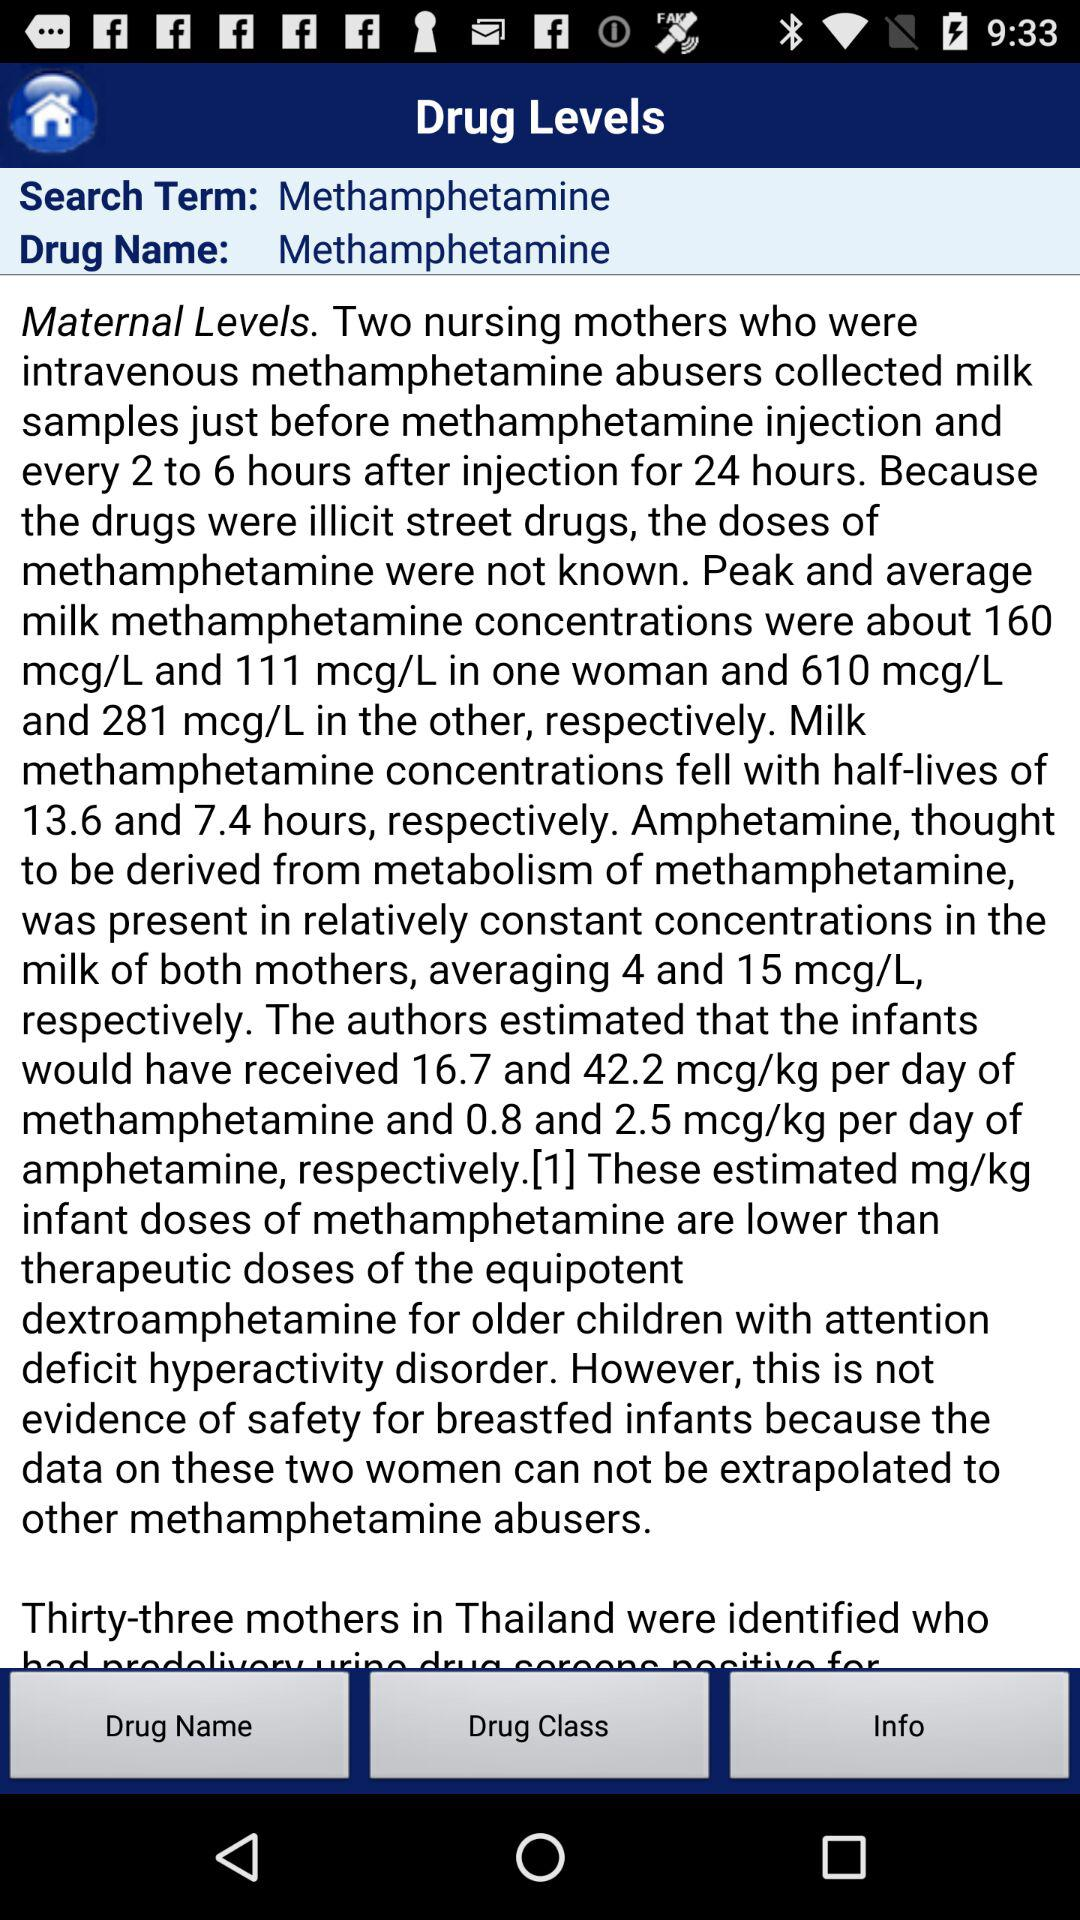What is the name of the drug? The name of the drug is "Methamphetamine". 